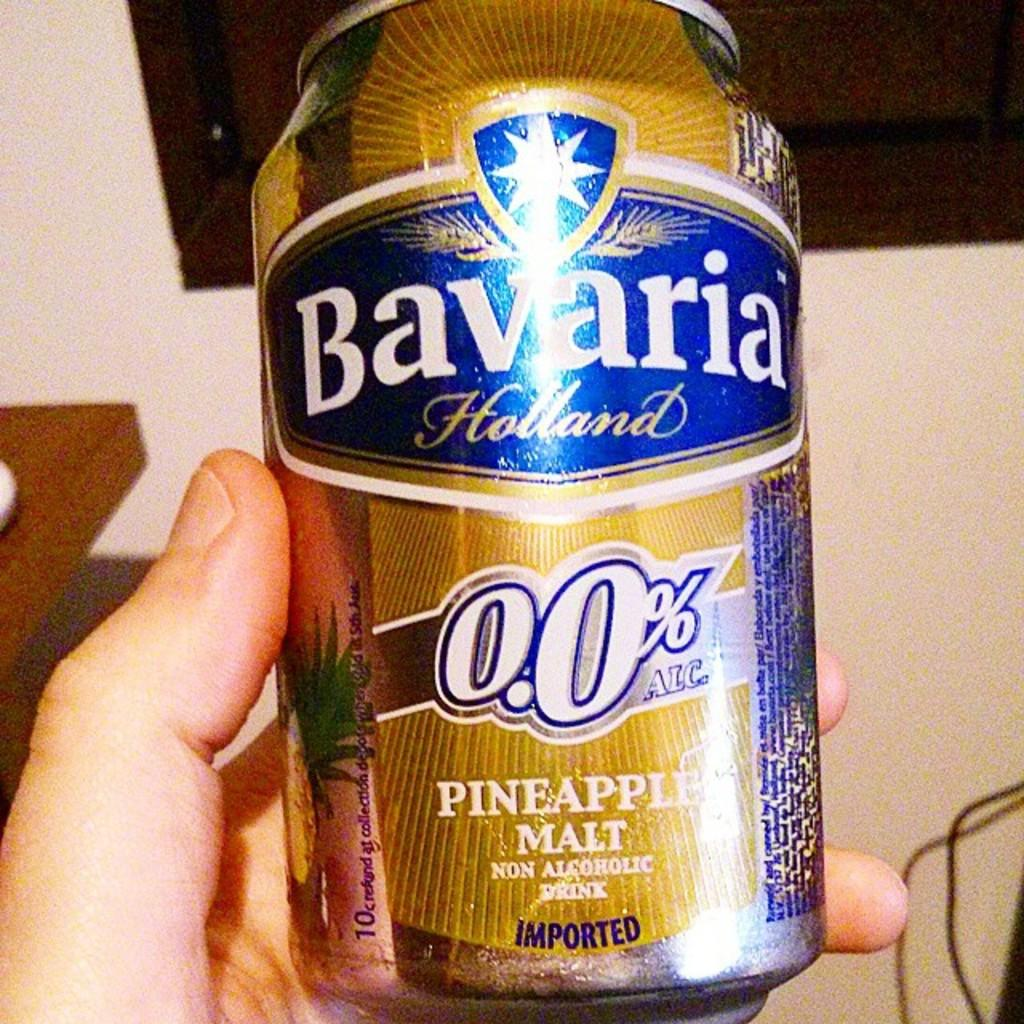<image>
Provide a brief description of the given image. A bottle of Bavaria Pineapple Malt is a non-alcoholic drink. 